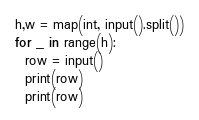<code> <loc_0><loc_0><loc_500><loc_500><_Python_>h,w = map(int, input().split())
for _ in range(h):
  row = input()
  print(row)
  print(row)</code> 